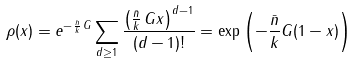<formula> <loc_0><loc_0><loc_500><loc_500>\rho ( x ) & = e ^ { - \frac { \bar { n } } { k } \, G } \sum _ { d \geq 1 } \frac { \left ( \frac { \bar { n } } { k } \, G x \right ) ^ { d - 1 } } { ( d - 1 ) ! } = \exp \left ( - \frac { \bar { n } } { k } G ( 1 - x ) \right )</formula> 